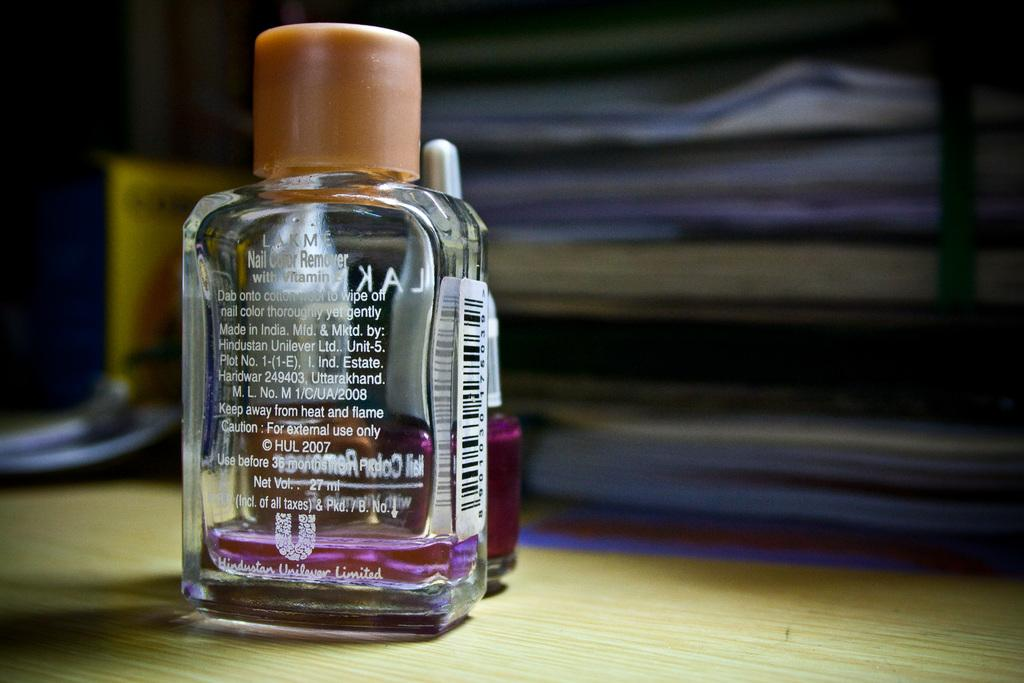<image>
Render a clear and concise summary of the photo. Nail Color Remover by Unilever sits on a table in front of a bottle of polish 